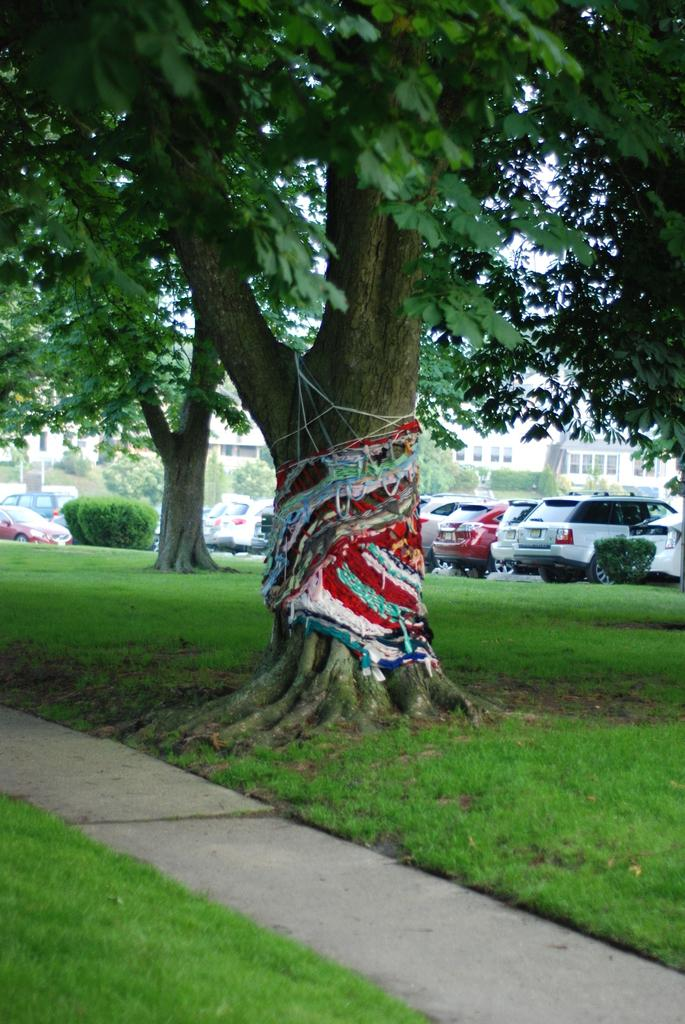What type of structures can be seen in the image? There are buildings in the image. What else is present in the image besides buildings? There are vehicles, shrubs, trees, and clothes hanging on one of the trees. Can you describe the ground visible at the bottom of the image? There is ground visible at the bottom of the image. What type of vegetation is present in the image? There are shrubs and trees in the image. What statement can be made about the basket in the image? There is no basket present in the image. 